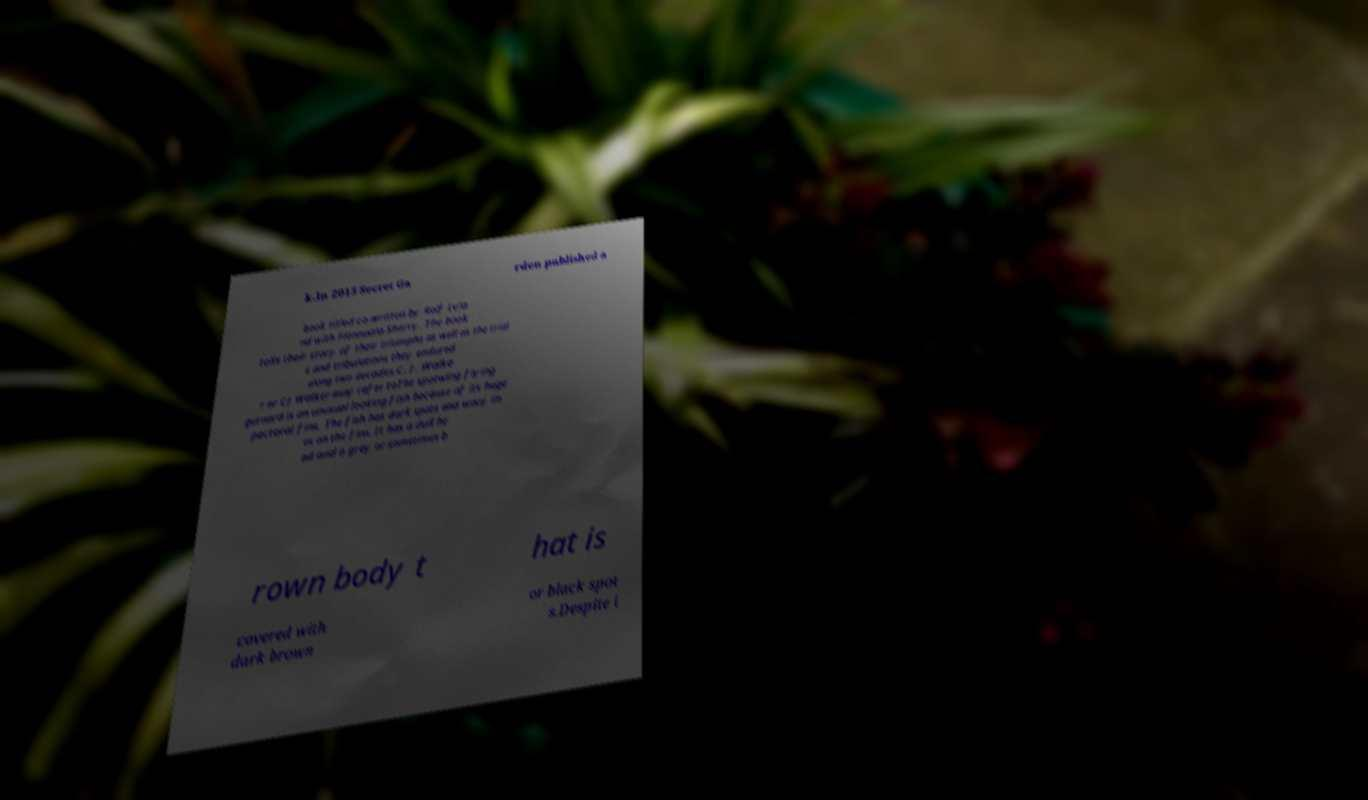Can you read and provide the text displayed in the image?This photo seems to have some interesting text. Can you extract and type it out for me? k.In 2015 Secret Ga rden published a book titled co-written by Rolf Lvla nd with Fionnuala Sherry. The book tells their story of their triumphs as well as the trial s and tribulations they endured along two decades.C. J. Walke r or CJ Walker may refer toThe spotwing flying gurnard is an unusual looking fish because of its huge pectoral fins. The fish has dark spots and wavy lin es on the fins. It has a dull he ad and a grey or sometimes b rown body t hat is covered with dark brown or black spot s.Despite i 